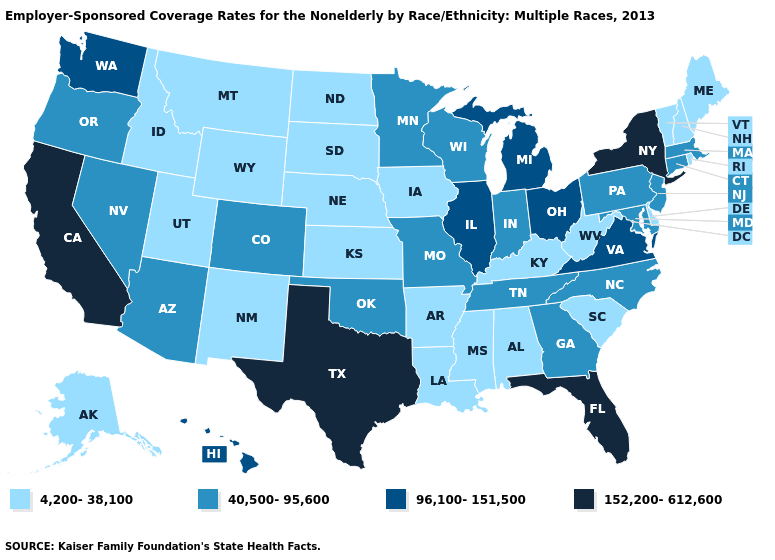What is the value of New Mexico?
Concise answer only. 4,200-38,100. Name the states that have a value in the range 40,500-95,600?
Be succinct. Arizona, Colorado, Connecticut, Georgia, Indiana, Maryland, Massachusetts, Minnesota, Missouri, Nevada, New Jersey, North Carolina, Oklahoma, Oregon, Pennsylvania, Tennessee, Wisconsin. Name the states that have a value in the range 40,500-95,600?
Answer briefly. Arizona, Colorado, Connecticut, Georgia, Indiana, Maryland, Massachusetts, Minnesota, Missouri, Nevada, New Jersey, North Carolina, Oklahoma, Oregon, Pennsylvania, Tennessee, Wisconsin. Name the states that have a value in the range 40,500-95,600?
Keep it brief. Arizona, Colorado, Connecticut, Georgia, Indiana, Maryland, Massachusetts, Minnesota, Missouri, Nevada, New Jersey, North Carolina, Oklahoma, Oregon, Pennsylvania, Tennessee, Wisconsin. What is the highest value in the South ?
Give a very brief answer. 152,200-612,600. Name the states that have a value in the range 152,200-612,600?
Answer briefly. California, Florida, New York, Texas. What is the value of Louisiana?
Write a very short answer. 4,200-38,100. Does Oregon have a higher value than South Dakota?
Concise answer only. Yes. Name the states that have a value in the range 96,100-151,500?
Short answer required. Hawaii, Illinois, Michigan, Ohio, Virginia, Washington. Does Texas have the highest value in the South?
Give a very brief answer. Yes. Which states hav the highest value in the MidWest?
Answer briefly. Illinois, Michigan, Ohio. Does Massachusetts have a lower value than Mississippi?
Short answer required. No. Which states have the highest value in the USA?
Keep it brief. California, Florida, New York, Texas. What is the highest value in the USA?
Short answer required. 152,200-612,600. Among the states that border North Dakota , which have the lowest value?
Keep it brief. Montana, South Dakota. 